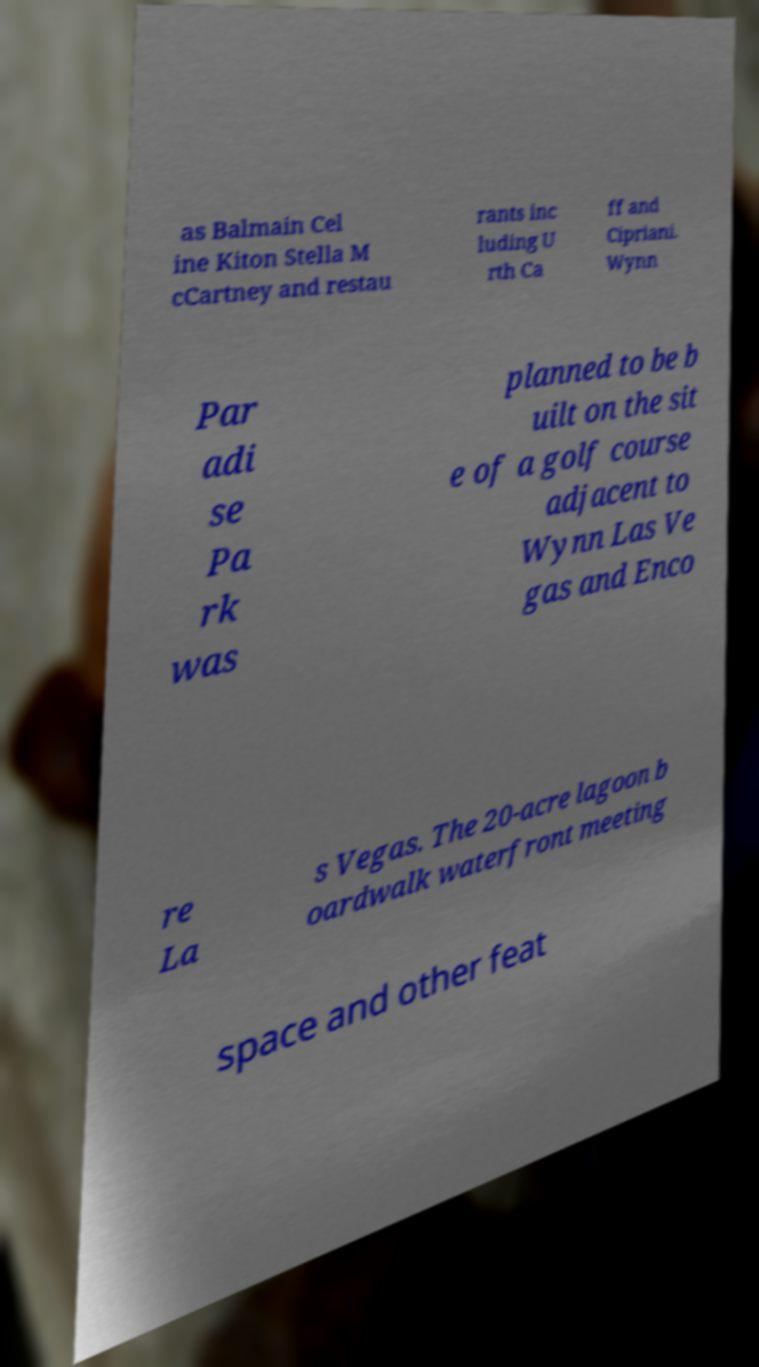Can you read and provide the text displayed in the image?This photo seems to have some interesting text. Can you extract and type it out for me? as Balmain Cel ine Kiton Stella M cCartney and restau rants inc luding U rth Ca ff and Cipriani. Wynn Par adi se Pa rk was planned to be b uilt on the sit e of a golf course adjacent to Wynn Las Ve gas and Enco re La s Vegas. The 20-acre lagoon b oardwalk waterfront meeting space and other feat 